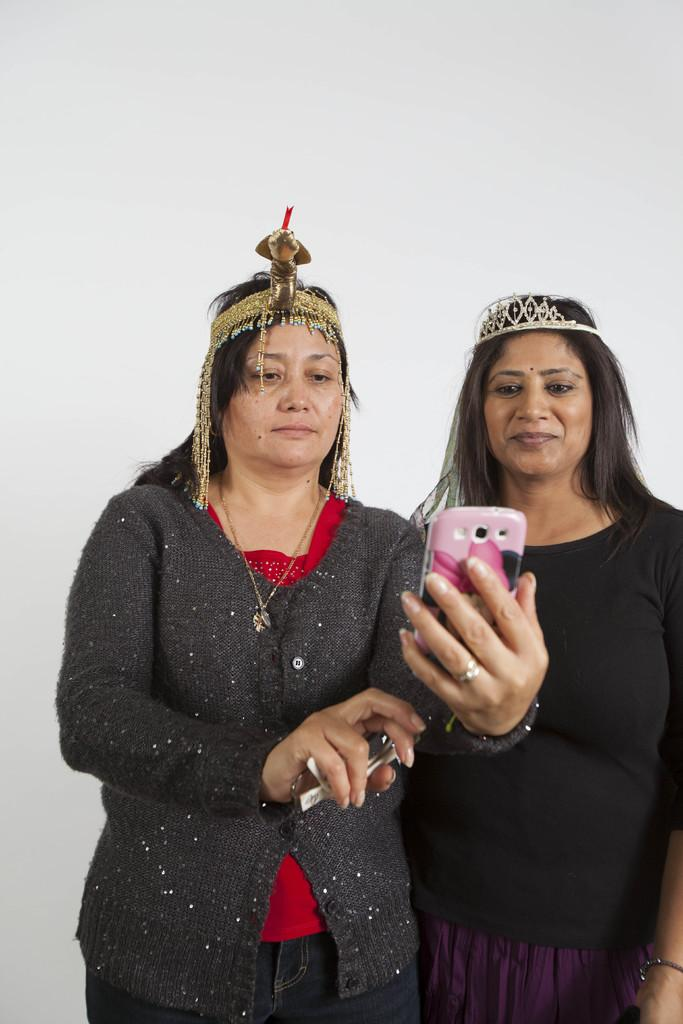How many women are in the image? There are two women in the image. What are the women wearing? Both women are wearing black jackets. What is the woman on the left side holding? The woman on the left side is holding a mobile phone. What is the color of the background in the image? The background of the image is white. Can you tell me how many hearts are visible in the image? There are no hearts visible in the image. What type of expert is present in the image? There is no expert present in the image; it features two women wearing black jackets. 